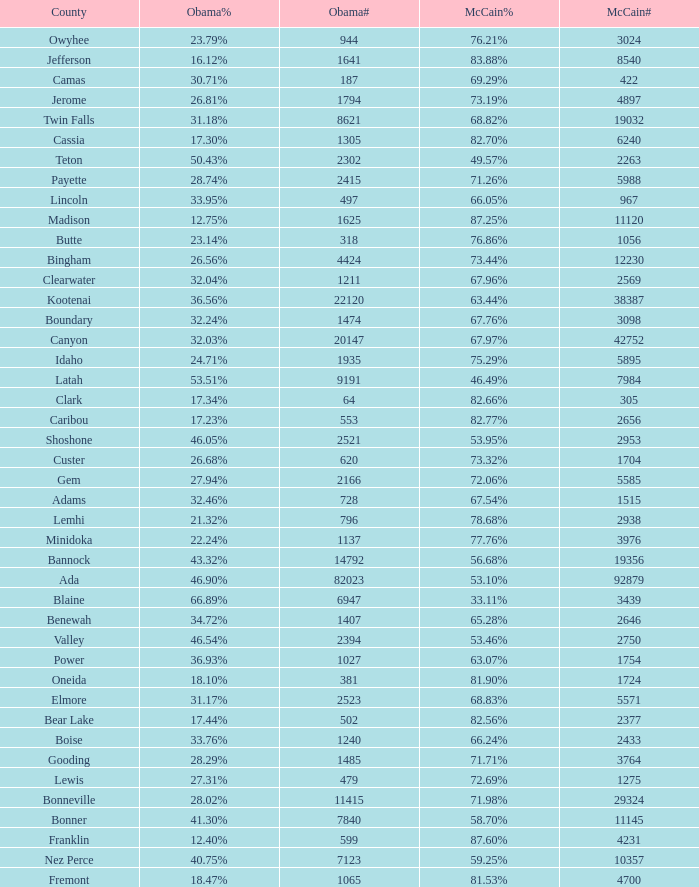What is the maximum McCain population turnout number? 92879.0. 